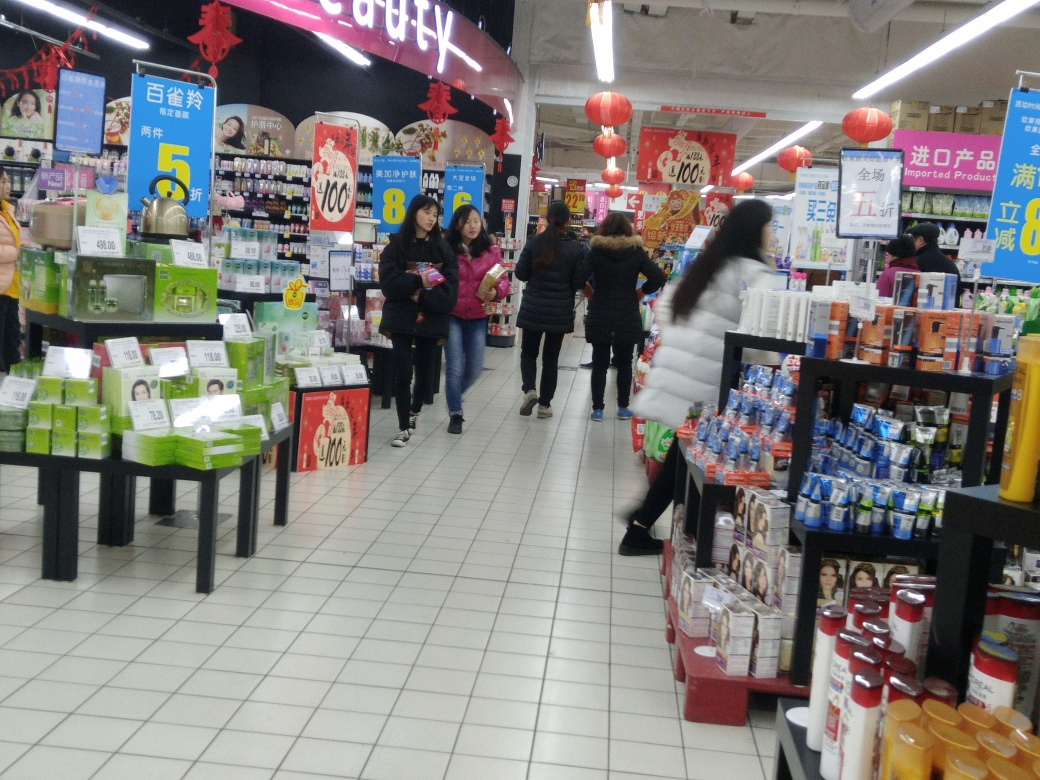What kinds of products are on sale in the supermarket? The supermarket features a variety of items for sale. There are self-care products such as skin creams and hair care visible on the displays. Additionally, we can see some shelves stocked with food items and drinks. Promotional signs highlight discounts on select products, enticing customers to make purchases based on savings. 